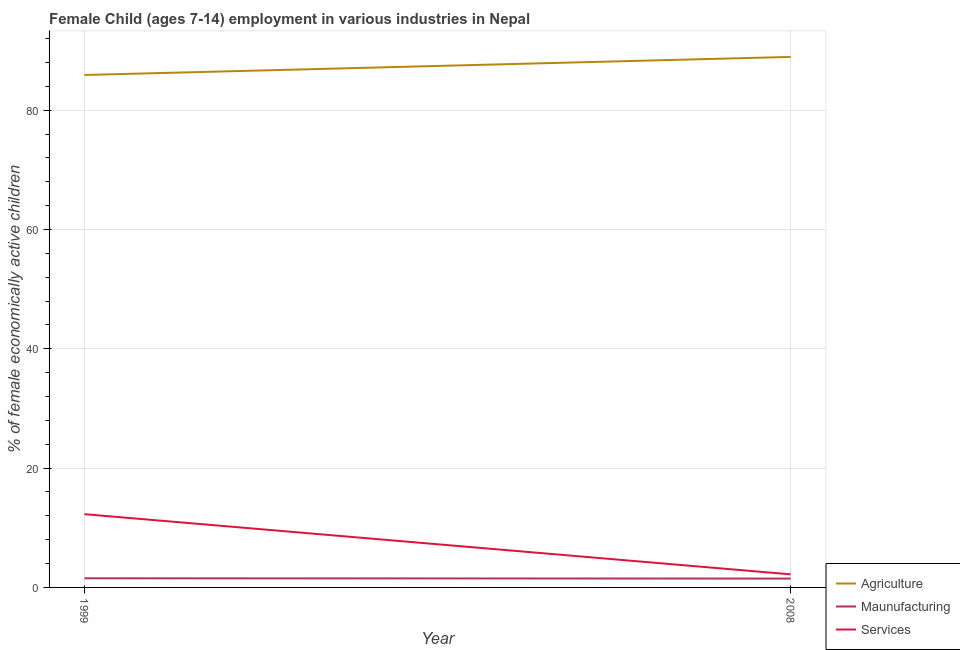Is the number of lines equal to the number of legend labels?
Keep it short and to the point. Yes. What is the percentage of economically active children in services in 2008?
Ensure brevity in your answer.  2.19. Across all years, what is the maximum percentage of economically active children in agriculture?
Offer a terse response. 88.93. Across all years, what is the minimum percentage of economically active children in services?
Provide a short and direct response. 2.19. In which year was the percentage of economically active children in manufacturing maximum?
Your response must be concise. 1999. What is the total percentage of economically active children in agriculture in the graph?
Make the answer very short. 174.83. What is the difference between the percentage of economically active children in services in 1999 and that in 2008?
Provide a short and direct response. 10.09. What is the difference between the percentage of economically active children in agriculture in 2008 and the percentage of economically active children in manufacturing in 1999?
Your response must be concise. 87.4. What is the average percentage of economically active children in services per year?
Give a very brief answer. 7.23. In the year 1999, what is the difference between the percentage of economically active children in manufacturing and percentage of economically active children in agriculture?
Provide a succinct answer. -84.37. In how many years, is the percentage of economically active children in manufacturing greater than 20 %?
Make the answer very short. 0. What is the ratio of the percentage of economically active children in manufacturing in 1999 to that in 2008?
Ensure brevity in your answer.  1.03. Is it the case that in every year, the sum of the percentage of economically active children in agriculture and percentage of economically active children in manufacturing is greater than the percentage of economically active children in services?
Make the answer very short. Yes. Is the percentage of economically active children in services strictly greater than the percentage of economically active children in manufacturing over the years?
Make the answer very short. Yes. Is the percentage of economically active children in agriculture strictly less than the percentage of economically active children in services over the years?
Offer a very short reply. No. How many years are there in the graph?
Make the answer very short. 2. Are the values on the major ticks of Y-axis written in scientific E-notation?
Provide a short and direct response. No. Does the graph contain grids?
Your response must be concise. Yes. What is the title of the graph?
Offer a very short reply. Female Child (ages 7-14) employment in various industries in Nepal. Does "Transport services" appear as one of the legend labels in the graph?
Make the answer very short. No. What is the label or title of the Y-axis?
Provide a succinct answer. % of female economically active children. What is the % of female economically active children of Agriculture in 1999?
Offer a terse response. 85.9. What is the % of female economically active children in Maunufacturing in 1999?
Offer a terse response. 1.53. What is the % of female economically active children of Services in 1999?
Provide a short and direct response. 12.28. What is the % of female economically active children of Agriculture in 2008?
Keep it short and to the point. 88.93. What is the % of female economically active children of Maunufacturing in 2008?
Provide a succinct answer. 1.48. What is the % of female economically active children in Services in 2008?
Give a very brief answer. 2.19. Across all years, what is the maximum % of female economically active children of Agriculture?
Make the answer very short. 88.93. Across all years, what is the maximum % of female economically active children of Maunufacturing?
Provide a succinct answer. 1.53. Across all years, what is the maximum % of female economically active children of Services?
Provide a short and direct response. 12.28. Across all years, what is the minimum % of female economically active children of Agriculture?
Make the answer very short. 85.9. Across all years, what is the minimum % of female economically active children of Maunufacturing?
Your answer should be compact. 1.48. Across all years, what is the minimum % of female economically active children of Services?
Provide a succinct answer. 2.19. What is the total % of female economically active children in Agriculture in the graph?
Your response must be concise. 174.83. What is the total % of female economically active children in Maunufacturing in the graph?
Keep it short and to the point. 3.01. What is the total % of female economically active children in Services in the graph?
Provide a succinct answer. 14.47. What is the difference between the % of female economically active children in Agriculture in 1999 and that in 2008?
Ensure brevity in your answer.  -3.03. What is the difference between the % of female economically active children in Maunufacturing in 1999 and that in 2008?
Ensure brevity in your answer.  0.05. What is the difference between the % of female economically active children in Services in 1999 and that in 2008?
Give a very brief answer. 10.09. What is the difference between the % of female economically active children in Agriculture in 1999 and the % of female economically active children in Maunufacturing in 2008?
Keep it short and to the point. 84.42. What is the difference between the % of female economically active children of Agriculture in 1999 and the % of female economically active children of Services in 2008?
Offer a very short reply. 83.71. What is the difference between the % of female economically active children of Maunufacturing in 1999 and the % of female economically active children of Services in 2008?
Offer a terse response. -0.66. What is the average % of female economically active children in Agriculture per year?
Keep it short and to the point. 87.42. What is the average % of female economically active children in Maunufacturing per year?
Keep it short and to the point. 1.51. What is the average % of female economically active children of Services per year?
Your answer should be very brief. 7.24. In the year 1999, what is the difference between the % of female economically active children in Agriculture and % of female economically active children in Maunufacturing?
Your answer should be very brief. 84.37. In the year 1999, what is the difference between the % of female economically active children of Agriculture and % of female economically active children of Services?
Keep it short and to the point. 73.62. In the year 1999, what is the difference between the % of female economically active children of Maunufacturing and % of female economically active children of Services?
Give a very brief answer. -10.75. In the year 2008, what is the difference between the % of female economically active children in Agriculture and % of female economically active children in Maunufacturing?
Provide a short and direct response. 87.45. In the year 2008, what is the difference between the % of female economically active children of Agriculture and % of female economically active children of Services?
Provide a succinct answer. 86.74. In the year 2008, what is the difference between the % of female economically active children in Maunufacturing and % of female economically active children in Services?
Your answer should be compact. -0.71. What is the ratio of the % of female economically active children in Agriculture in 1999 to that in 2008?
Provide a short and direct response. 0.97. What is the ratio of the % of female economically active children of Maunufacturing in 1999 to that in 2008?
Provide a short and direct response. 1.03. What is the ratio of the % of female economically active children in Services in 1999 to that in 2008?
Make the answer very short. 5.61. What is the difference between the highest and the second highest % of female economically active children in Agriculture?
Give a very brief answer. 3.03. What is the difference between the highest and the second highest % of female economically active children in Maunufacturing?
Offer a very short reply. 0.05. What is the difference between the highest and the second highest % of female economically active children of Services?
Make the answer very short. 10.09. What is the difference between the highest and the lowest % of female economically active children in Agriculture?
Keep it short and to the point. 3.03. What is the difference between the highest and the lowest % of female economically active children of Maunufacturing?
Ensure brevity in your answer.  0.05. What is the difference between the highest and the lowest % of female economically active children in Services?
Your answer should be very brief. 10.09. 